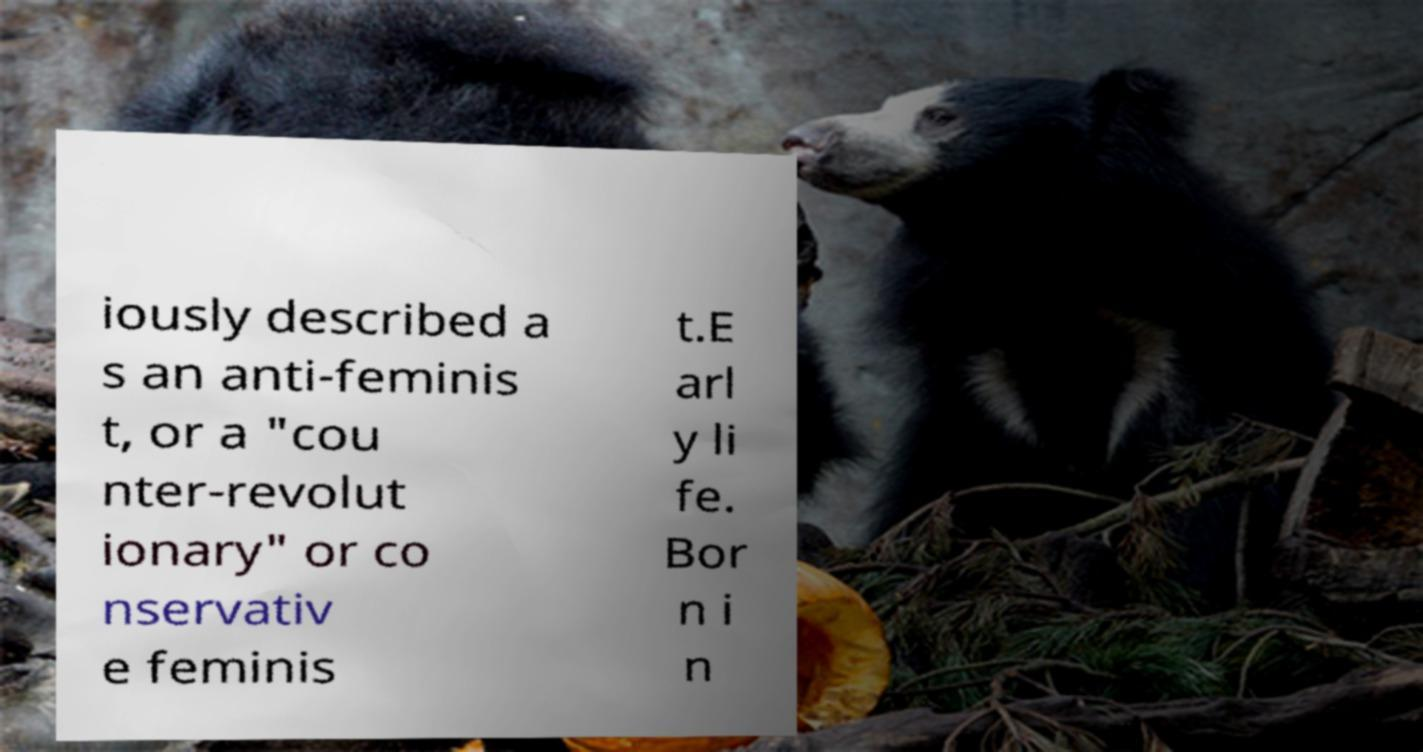There's text embedded in this image that I need extracted. Can you transcribe it verbatim? iously described a s an anti-feminis t, or a "cou nter-revolut ionary" or co nservativ e feminis t.E arl y li fe. Bor n i n 